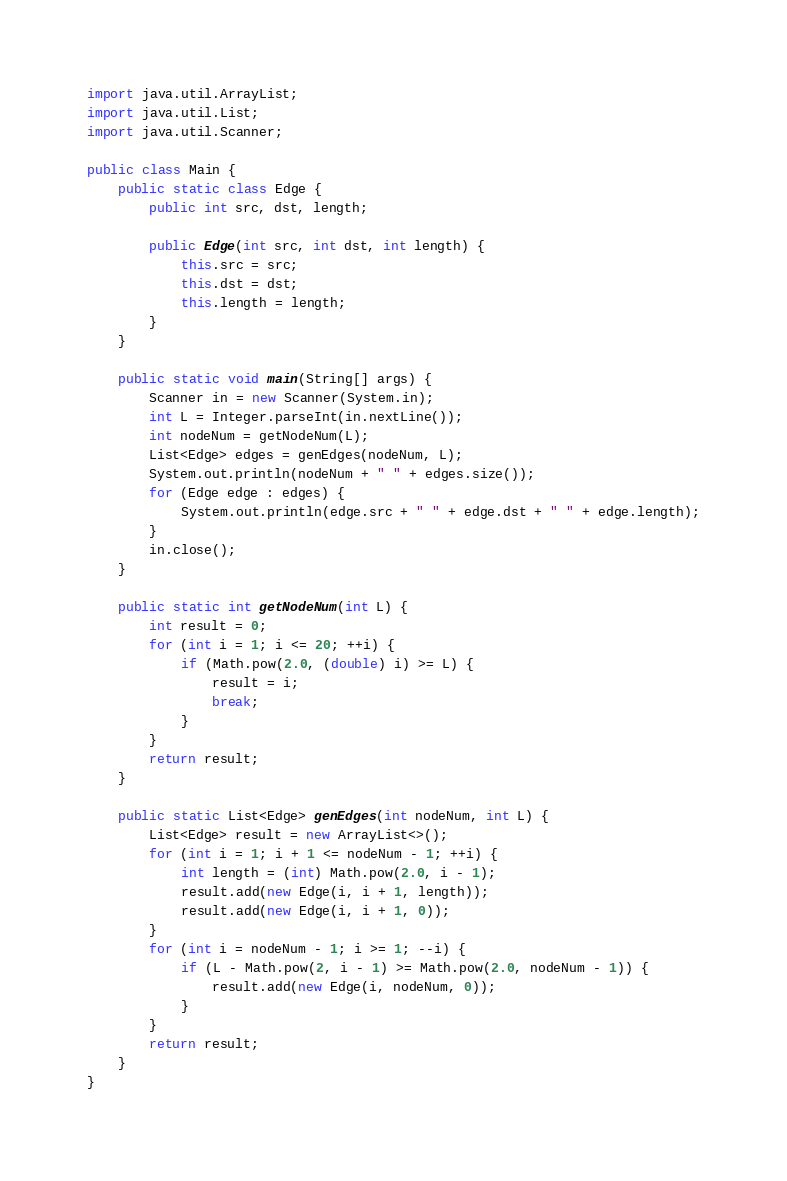<code> <loc_0><loc_0><loc_500><loc_500><_Java_>import java.util.ArrayList;
import java.util.List;
import java.util.Scanner;

public class Main {
	public static class Edge {
		public int src, dst, length;

		public Edge(int src, int dst, int length) {
			this.src = src;
			this.dst = dst;
			this.length = length;
		}
	}

	public static void main(String[] args) {
		Scanner in = new Scanner(System.in);
		int L = Integer.parseInt(in.nextLine());
		int nodeNum = getNodeNum(L);
		List<Edge> edges = genEdges(nodeNum, L);
		System.out.println(nodeNum + " " + edges.size());
		for (Edge edge : edges) {
			System.out.println(edge.src + " " + edge.dst + " " + edge.length);
		}
		in.close();
	}

	public static int getNodeNum(int L) {
		int result = 0;
		for (int i = 1; i <= 20; ++i) {
			if (Math.pow(2.0, (double) i) >= L) {
				result = i;
				break;
			}
		}
		return result;
	}

	public static List<Edge> genEdges(int nodeNum, int L) {
		List<Edge> result = new ArrayList<>();
		for (int i = 1; i + 1 <= nodeNum - 1; ++i) {
			int length = (int) Math.pow(2.0, i - 1);
			result.add(new Edge(i, i + 1, length));
			result.add(new Edge(i, i + 1, 0));
		}
		for (int i = nodeNum - 1; i >= 1; --i) {
			if (L - Math.pow(2, i - 1) >= Math.pow(2.0, nodeNum - 1)) {
				result.add(new Edge(i, nodeNum, 0));
			}
		}
		return result;
	}
}</code> 